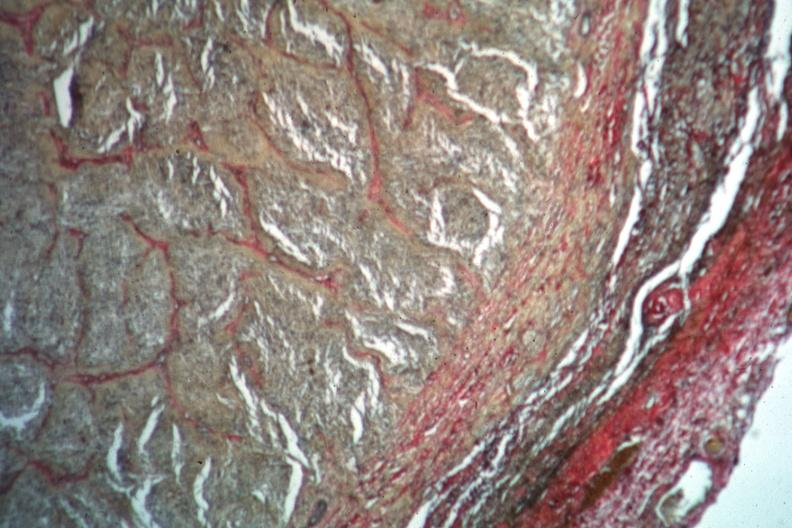what is present?
Answer the question using a single word or phrase. Glioma 